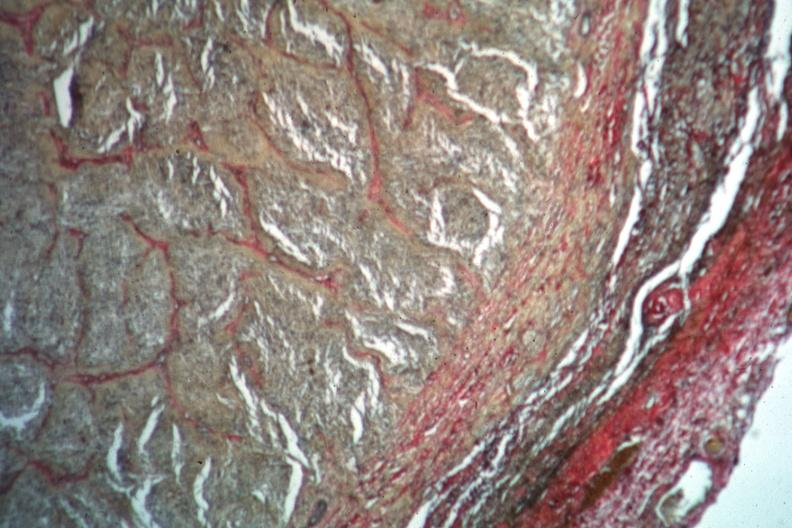what is present?
Answer the question using a single word or phrase. Glioma 